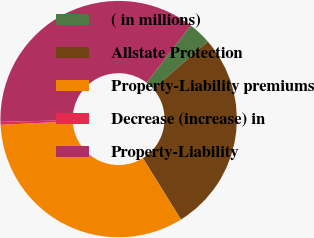Convert chart. <chart><loc_0><loc_0><loc_500><loc_500><pie_chart><fcel>( in millions)<fcel>Allstate Protection<fcel>Property-Liability premiums<fcel>Decrease (increase) in<fcel>Property-Liability<nl><fcel>3.15%<fcel>27.56%<fcel>33.07%<fcel>0.4%<fcel>35.82%<nl></chart> 